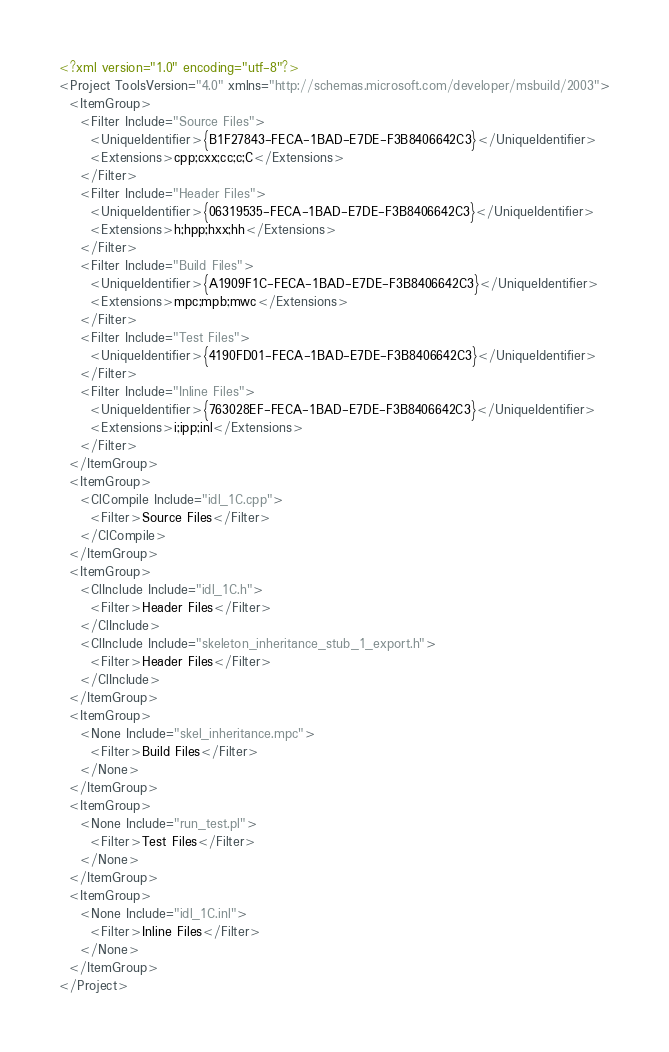Convert code to text. <code><loc_0><loc_0><loc_500><loc_500><_XML_><?xml version="1.0" encoding="utf-8"?>
<Project ToolsVersion="4.0" xmlns="http://schemas.microsoft.com/developer/msbuild/2003">
  <ItemGroup>
    <Filter Include="Source Files">
      <UniqueIdentifier>{B1F27843-FECA-1BAD-E7DE-F3B8406642C3}</UniqueIdentifier>
      <Extensions>cpp;cxx;cc;c;C</Extensions>
    </Filter>
    <Filter Include="Header Files">
      <UniqueIdentifier>{06319535-FECA-1BAD-E7DE-F3B8406642C3}</UniqueIdentifier>
      <Extensions>h;hpp;hxx;hh</Extensions>
    </Filter>
    <Filter Include="Build Files">
      <UniqueIdentifier>{A1909F1C-FECA-1BAD-E7DE-F3B8406642C3}</UniqueIdentifier>
      <Extensions>mpc;mpb;mwc</Extensions>
    </Filter>
    <Filter Include="Test Files">
      <UniqueIdentifier>{4190FD01-FECA-1BAD-E7DE-F3B8406642C3}</UniqueIdentifier>
    </Filter>
    <Filter Include="Inline Files">
      <UniqueIdentifier>{763028EF-FECA-1BAD-E7DE-F3B8406642C3}</UniqueIdentifier>
      <Extensions>i;ipp;inl</Extensions>
    </Filter>
  </ItemGroup>
  <ItemGroup>
    <ClCompile Include="idl_1C.cpp">
      <Filter>Source Files</Filter>
    </ClCompile>
  </ItemGroup>
  <ItemGroup>
    <ClInclude Include="idl_1C.h">
      <Filter>Header Files</Filter>
    </ClInclude>
    <ClInclude Include="skeleton_inheritance_stub_1_export.h">
      <Filter>Header Files</Filter>
    </ClInclude>
  </ItemGroup>
  <ItemGroup>
    <None Include="skel_inheritance.mpc">
      <Filter>Build Files</Filter>
    </None>
  </ItemGroup>
  <ItemGroup>
    <None Include="run_test.pl">
      <Filter>Test Files</Filter>
    </None>
  </ItemGroup>
  <ItemGroup>
    <None Include="idl_1C.inl">
      <Filter>Inline Files</Filter>
    </None>
  </ItemGroup>
</Project>
</code> 